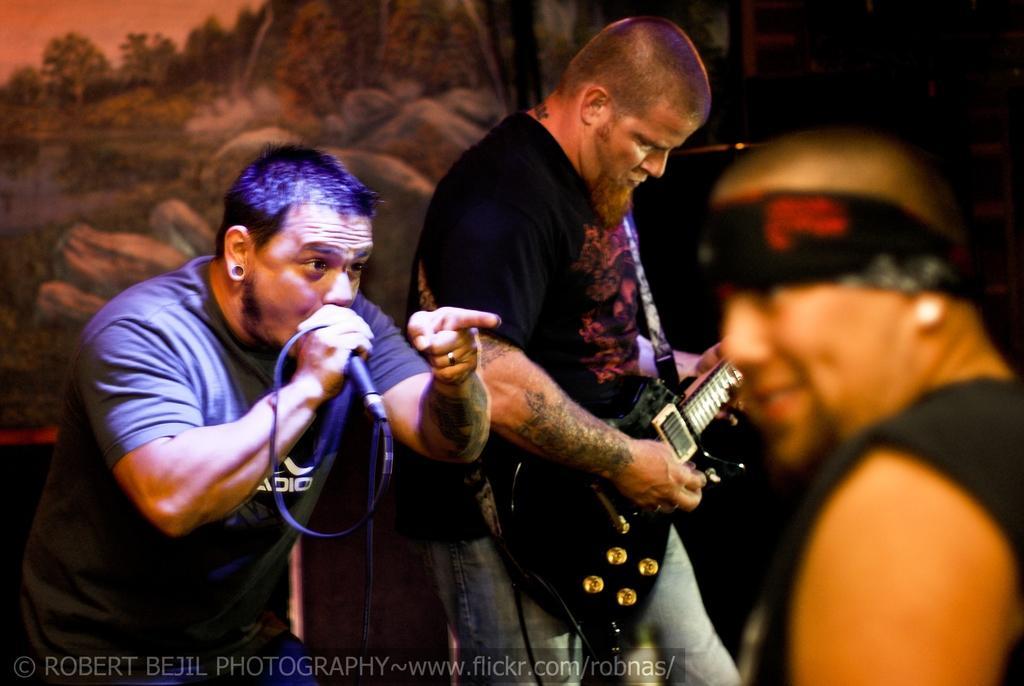Describe this image in one or two sentences. In this image there are three persons, person with black t- shirt is playing guitar and the other person is holding microphone. There is a painting at the back side. 